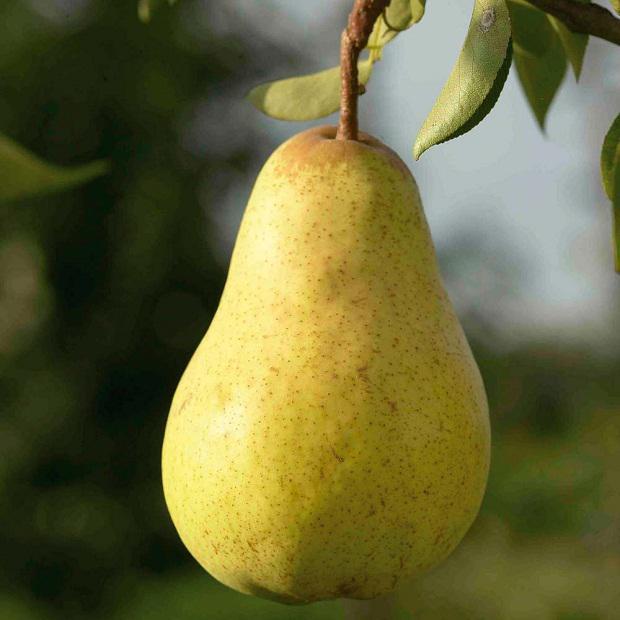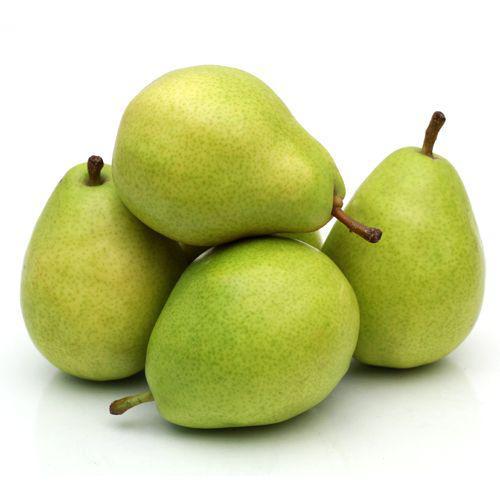The first image is the image on the left, the second image is the image on the right. Given the left and right images, does the statement "The left image includes at least one whole pear and a green leaf, and the right image contains at least three whole pears but no leaves." hold true? Answer yes or no. Yes. The first image is the image on the left, the second image is the image on the right. For the images shown, is this caption "At least one of the images shows fruit hanging on a tree." true? Answer yes or no. Yes. 